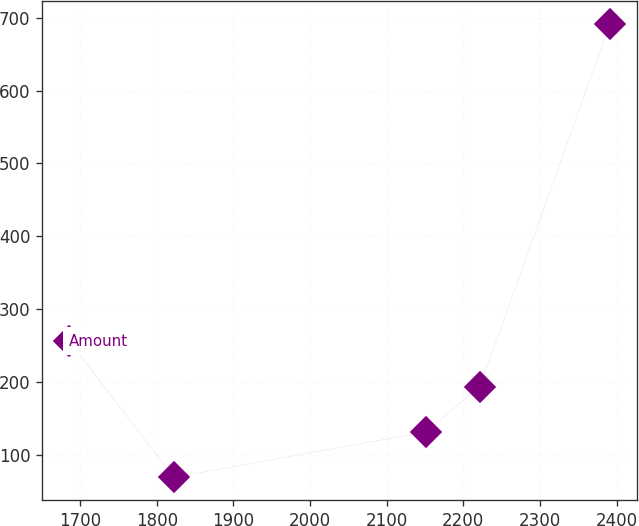Convert chart to OTSL. <chart><loc_0><loc_0><loc_500><loc_500><line_chart><ecel><fcel>Amount<nl><fcel>1685.49<fcel>255.9<nl><fcel>1822.38<fcel>68.94<nl><fcel>2151.13<fcel>131.26<nl><fcel>2221.75<fcel>193.58<nl><fcel>2391.68<fcel>692.14<nl></chart> 